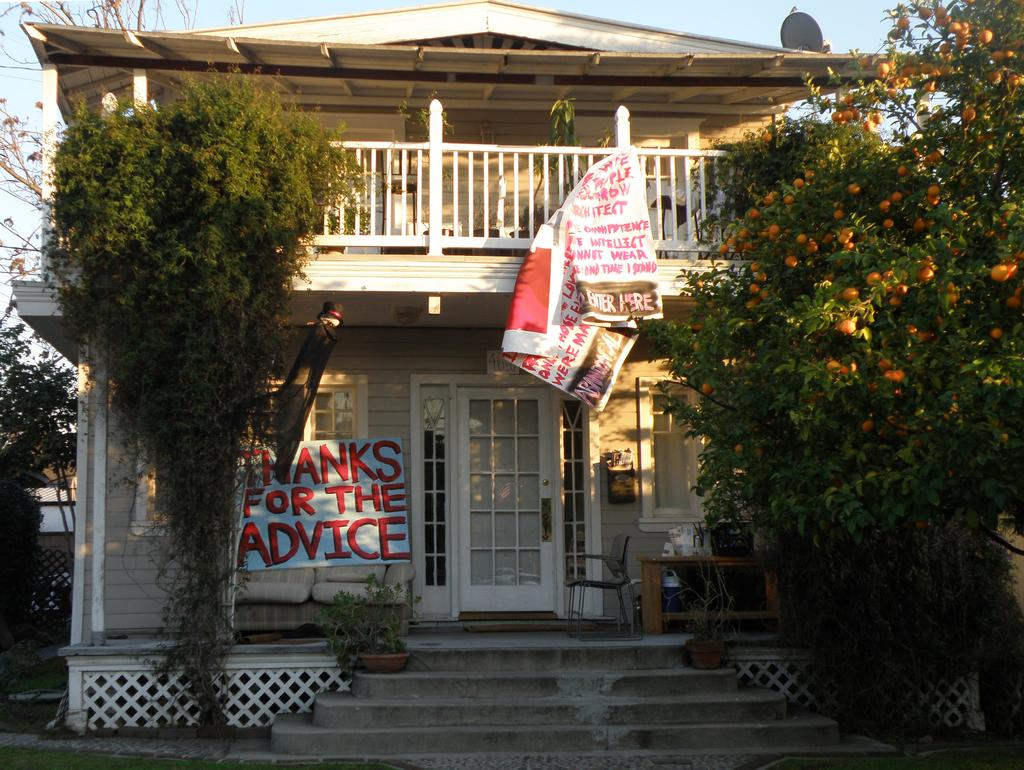<image>
Create a compact narrative representing the image presented. A house with a banner on the front that reads "Thanks for the advice" 